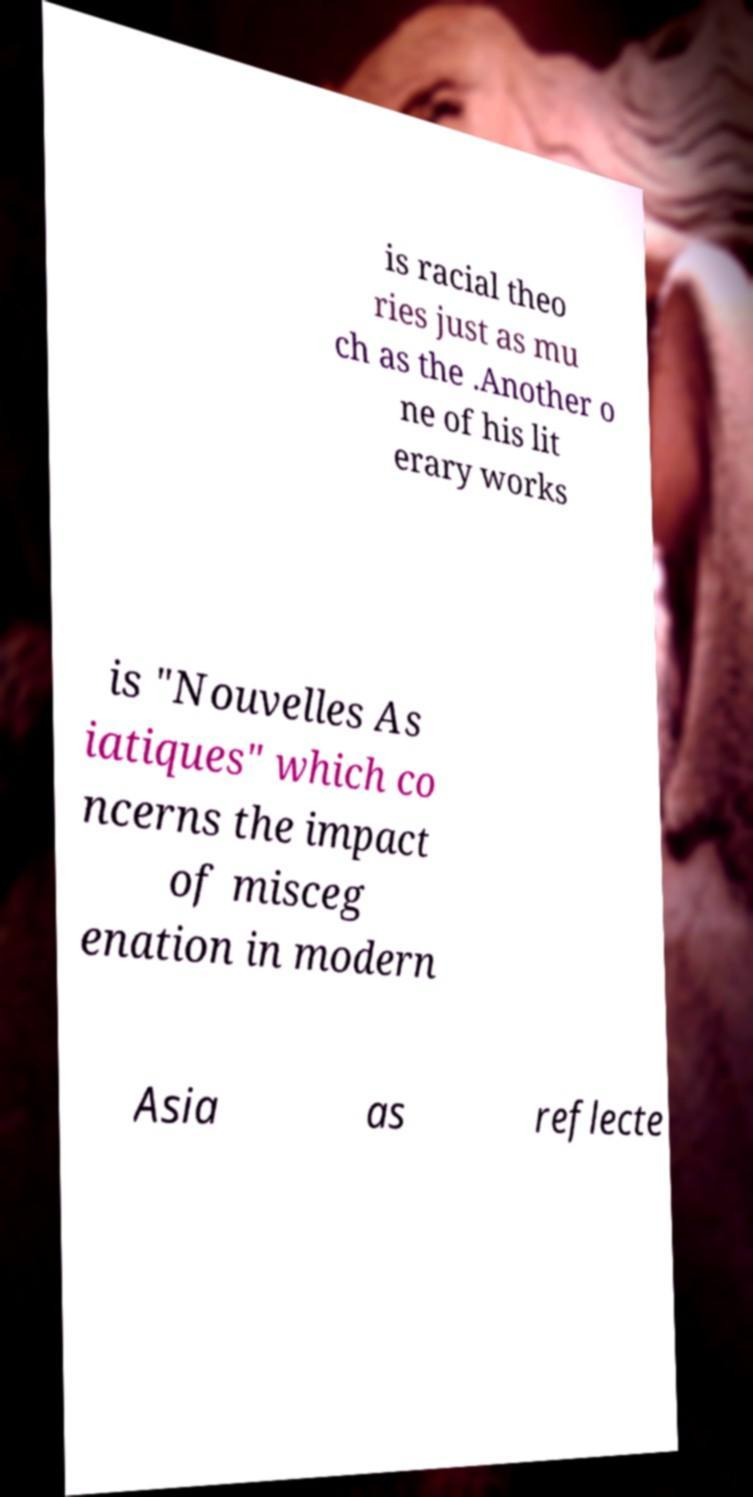There's text embedded in this image that I need extracted. Can you transcribe it verbatim? is racial theo ries just as mu ch as the .Another o ne of his lit erary works is "Nouvelles As iatiques" which co ncerns the impact of misceg enation in modern Asia as reflecte 